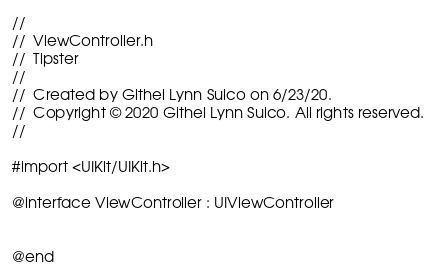Convert code to text. <code><loc_0><loc_0><loc_500><loc_500><_C_>//
//  ViewController.h
//  Tipster
//
//  Created by Githel Lynn Suico on 6/23/20.
//  Copyright © 2020 Githel Lynn Suico. All rights reserved.
//

#import <UIKit/UIKit.h>

@interface ViewController : UIViewController


@end

</code> 